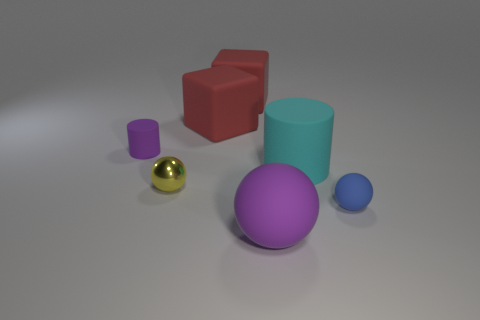Thinking about the composition, what can you tell me about the positioning of the objects and what it might imply? The objects are arranged in a way that gives balance to the composition, with varying sizes and colors distributed across the frame. It seems intentional, perhaps to showcase a contrast in shapes and sizes or to create an aesthetic that draws the viewer's eye across the scene. The arrangement might imply a study of geometry and spatial relationships. 